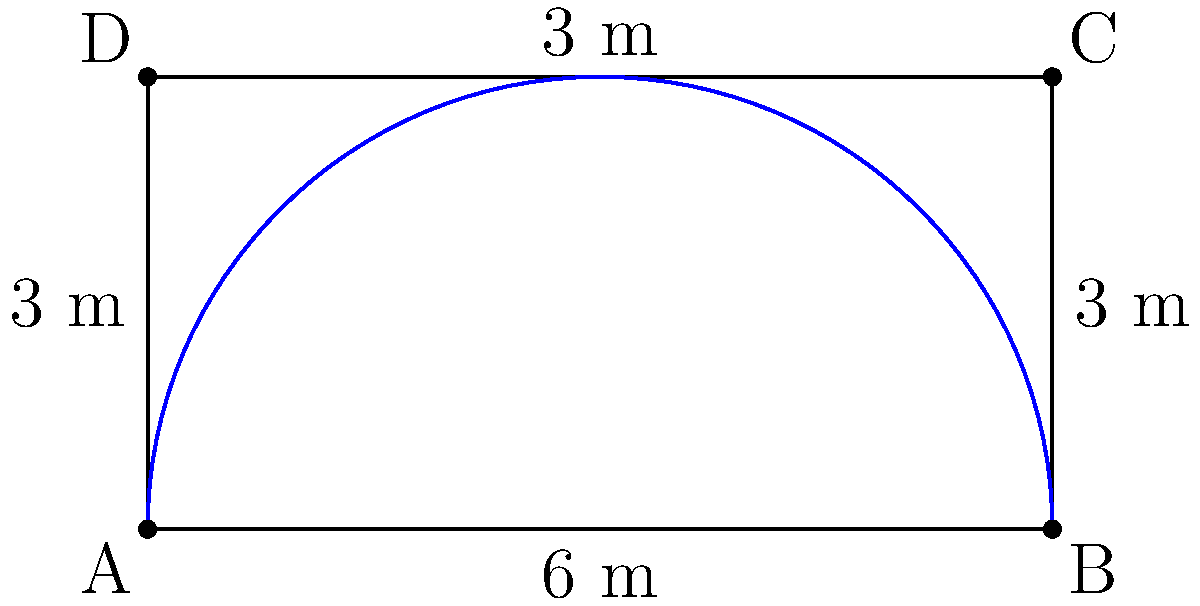In your lovely garden, you're planning a new flower bed. The bed is rectangular with a curved edge along one side, as shown in the diagram. If the straight sides measure 6 metres long and 3 metres wide, and the curved edge forms a perfect semicircle, what is the perimeter of the entire flower bed? Round your answer to the nearest centimetre. Let's approach this step-by-step, dear:

1) First, we need to calculate the length of the straight sides:
   - Two long sides: $2 \times 6$ m $= 12$ m
   - One short side: $3$ m
   Total straight sides: $12 + 3 = 15$ m

2) Now, for the curved edge. It's a semicircle, so we need to calculate half the circumference of a circle.
   
   The diameter of this semicircle is 6 m (the long side of the rectangle).
   
   The formula for the circumference of a circle is $\pi d$, where $d$ is the diameter.
   
   So, for half of this: $\frac{1}{2} \pi d = \frac{1}{2} \pi \times 6$

3) Let's calculate:
   $\frac{1}{2} \pi \times 6 \approx 9.4248$ m

4) Now, we add this to our straight sides:
   $15 + 9.4248 = 24.4248$ m

5) Rounding to the nearest centimetre:
   $24.42$ m or $2442$ cm

Therefore, the perimeter of the flower bed is approximately 24.42 metres or 2442 centimetres.
Answer: 24.42 m 